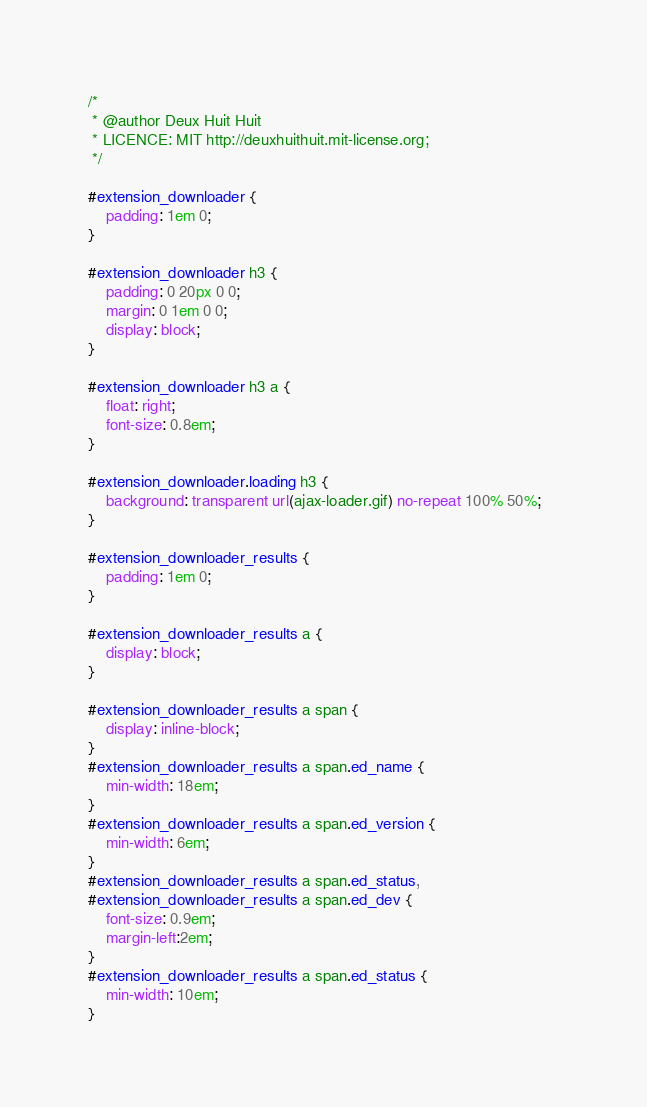Convert code to text. <code><loc_0><loc_0><loc_500><loc_500><_CSS_>/*
 * @author Deux Huit Huit
 * LICENCE: MIT http://deuxhuithuit.mit-license.org;
 */

#extension_downloader {
	padding: 1em 0;
}

#extension_downloader h3 {
	padding: 0 20px 0 0;
	margin: 0 1em 0 0;
	display: block;
}

#extension_downloader h3 a {
	float: right;
	font-size: 0.8em;
}

#extension_downloader.loading h3 {
	background: transparent url(ajax-loader.gif) no-repeat 100% 50%;	
}

#extension_downloader_results {
	padding: 1em 0;
}

#extension_downloader_results a {
	display: block;	
}

#extension_downloader_results a span {
	display: inline-block;	
}
#extension_downloader_results a span.ed_name {
	min-width: 18em;	
}
#extension_downloader_results a span.ed_version {
	min-width: 6em;	
}
#extension_downloader_results a span.ed_status,
#extension_downloader_results a span.ed_dev {
	font-size: 0.9em;
	margin-left:2em;
}
#extension_downloader_results a span.ed_status {
	min-width: 10em;
}</code> 